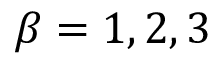Convert formula to latex. <formula><loc_0><loc_0><loc_500><loc_500>\beta = 1 , 2 , 3</formula> 